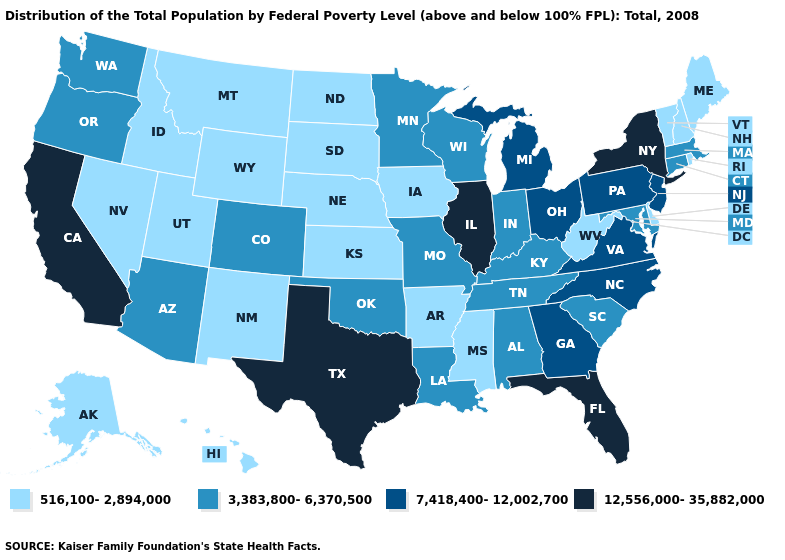Which states hav the highest value in the MidWest?
Keep it brief. Illinois. Does Illinois have a higher value than Texas?
Short answer required. No. Which states have the lowest value in the USA?
Quick response, please. Alaska, Arkansas, Delaware, Hawaii, Idaho, Iowa, Kansas, Maine, Mississippi, Montana, Nebraska, Nevada, New Hampshire, New Mexico, North Dakota, Rhode Island, South Dakota, Utah, Vermont, West Virginia, Wyoming. Among the states that border Utah , does Arizona have the highest value?
Concise answer only. Yes. What is the value of Pennsylvania?
Be succinct. 7,418,400-12,002,700. Does Arkansas have the lowest value in the USA?
Answer briefly. Yes. What is the value of Illinois?
Be succinct. 12,556,000-35,882,000. What is the value of Nebraska?
Keep it brief. 516,100-2,894,000. What is the highest value in the USA?
Short answer required. 12,556,000-35,882,000. Name the states that have a value in the range 3,383,800-6,370,500?
Short answer required. Alabama, Arizona, Colorado, Connecticut, Indiana, Kentucky, Louisiana, Maryland, Massachusetts, Minnesota, Missouri, Oklahoma, Oregon, South Carolina, Tennessee, Washington, Wisconsin. Does Connecticut have the same value as Florida?
Concise answer only. No. What is the value of New Mexico?
Keep it brief. 516,100-2,894,000. Among the states that border Minnesota , which have the lowest value?
Short answer required. Iowa, North Dakota, South Dakota. Name the states that have a value in the range 3,383,800-6,370,500?
Concise answer only. Alabama, Arizona, Colorado, Connecticut, Indiana, Kentucky, Louisiana, Maryland, Massachusetts, Minnesota, Missouri, Oklahoma, Oregon, South Carolina, Tennessee, Washington, Wisconsin. 